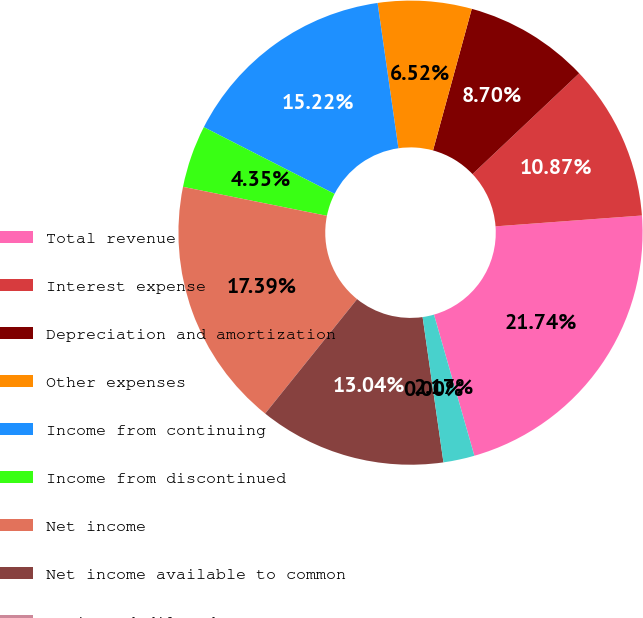Convert chart. <chart><loc_0><loc_0><loc_500><loc_500><pie_chart><fcel>Total revenue<fcel>Interest expense<fcel>Depreciation and amortization<fcel>Other expenses<fcel>Income from continuing<fcel>Income from discontinued<fcel>Net income<fcel>Net income available to common<fcel>Basic and diluted<fcel>Dividends paid per common<nl><fcel>21.74%<fcel>10.87%<fcel>8.7%<fcel>6.52%<fcel>15.22%<fcel>4.35%<fcel>17.39%<fcel>13.04%<fcel>0.0%<fcel>2.17%<nl></chart> 